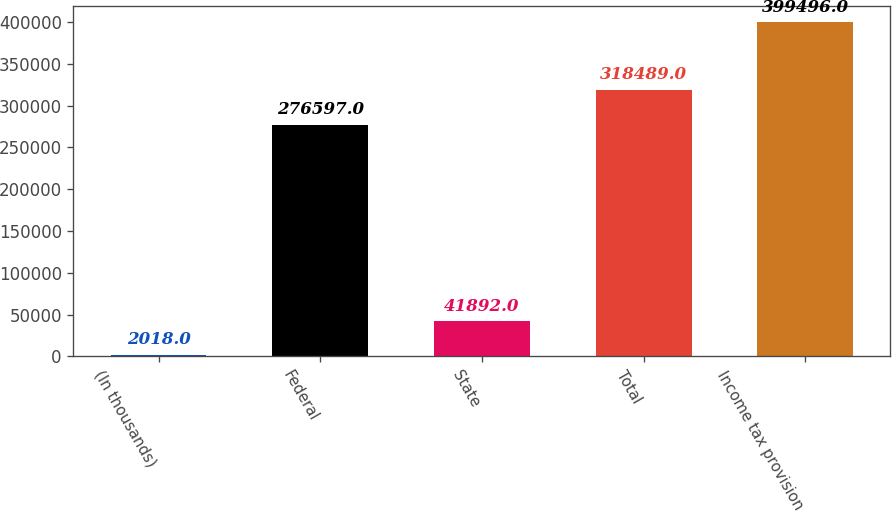Convert chart to OTSL. <chart><loc_0><loc_0><loc_500><loc_500><bar_chart><fcel>(In thousands)<fcel>Federal<fcel>State<fcel>Total<fcel>Income tax provision<nl><fcel>2018<fcel>276597<fcel>41892<fcel>318489<fcel>399496<nl></chart> 